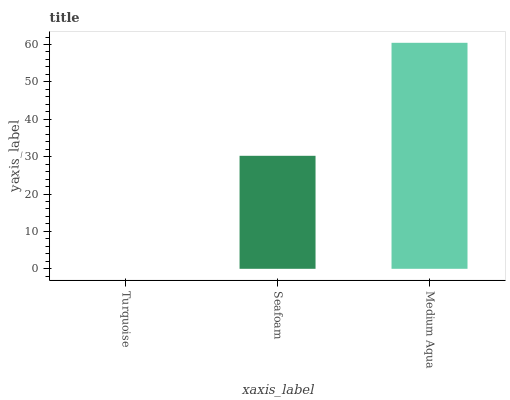Is Turquoise the minimum?
Answer yes or no. Yes. Is Medium Aqua the maximum?
Answer yes or no. Yes. Is Seafoam the minimum?
Answer yes or no. No. Is Seafoam the maximum?
Answer yes or no. No. Is Seafoam greater than Turquoise?
Answer yes or no. Yes. Is Turquoise less than Seafoam?
Answer yes or no. Yes. Is Turquoise greater than Seafoam?
Answer yes or no. No. Is Seafoam less than Turquoise?
Answer yes or no. No. Is Seafoam the high median?
Answer yes or no. Yes. Is Seafoam the low median?
Answer yes or no. Yes. Is Turquoise the high median?
Answer yes or no. No. Is Medium Aqua the low median?
Answer yes or no. No. 